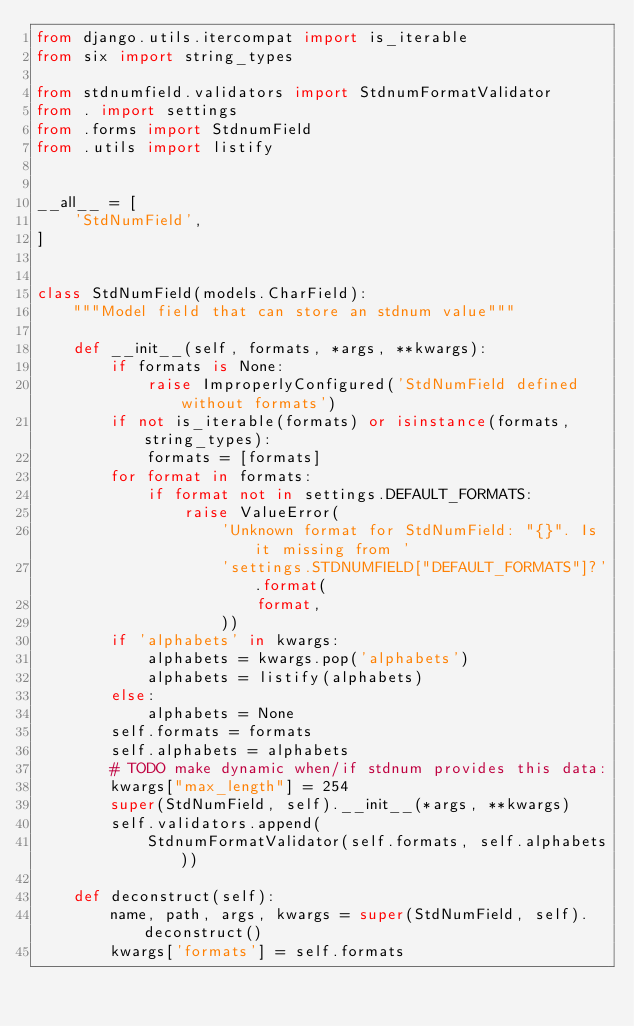Convert code to text. <code><loc_0><loc_0><loc_500><loc_500><_Python_>from django.utils.itercompat import is_iterable
from six import string_types

from stdnumfield.validators import StdnumFormatValidator
from . import settings
from .forms import StdnumField
from .utils import listify


__all__ = [
    'StdNumField',
]


class StdNumField(models.CharField):
    """Model field that can store an stdnum value"""

    def __init__(self, formats, *args, **kwargs):
        if formats is None:
            raise ImproperlyConfigured('StdNumField defined without formats')
        if not is_iterable(formats) or isinstance(formats, string_types):
            formats = [formats]
        for format in formats:
            if format not in settings.DEFAULT_FORMATS:
                raise ValueError(
                    'Unknown format for StdNumField: "{}". Is it missing from '
                    'settings.STDNUMFIELD["DEFAULT_FORMATS"]?'.format(
                        format,
                    ))
        if 'alphabets' in kwargs:
            alphabets = kwargs.pop('alphabets')
            alphabets = listify(alphabets)
        else:
            alphabets = None
        self.formats = formats
        self.alphabets = alphabets
        # TODO make dynamic when/if stdnum provides this data:
        kwargs["max_length"] = 254
        super(StdNumField, self).__init__(*args, **kwargs)
        self.validators.append(
            StdnumFormatValidator(self.formats, self.alphabets))

    def deconstruct(self):
        name, path, args, kwargs = super(StdNumField, self).deconstruct()
        kwargs['formats'] = self.formats</code> 